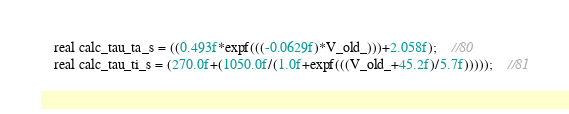<code> <loc_0><loc_0><loc_500><loc_500><_Cuda_>    real calc_tau_ta_s = ((0.493f*expf(((-0.0629f)*V_old_)))+2.058f);	//80
    real calc_tau_ti_s = (270.0f+(1050.0f/(1.0f+expf(((V_old_+45.2f)/5.7f)))));	//81</code> 